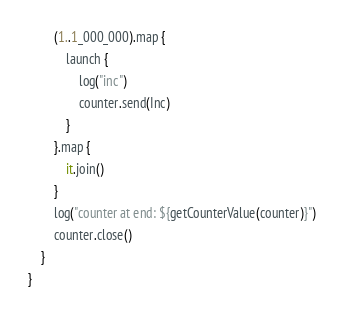Convert code to text. <code><loc_0><loc_0><loc_500><loc_500><_Kotlin_>        (1..1_000_000).map {
            launch {
                log("inc")
                counter.send(Inc)
            }
        }.map {
            it.join()
        }
        log("counter at end: ${getCounterValue(counter)}")
        counter.close()
    }
}

</code> 